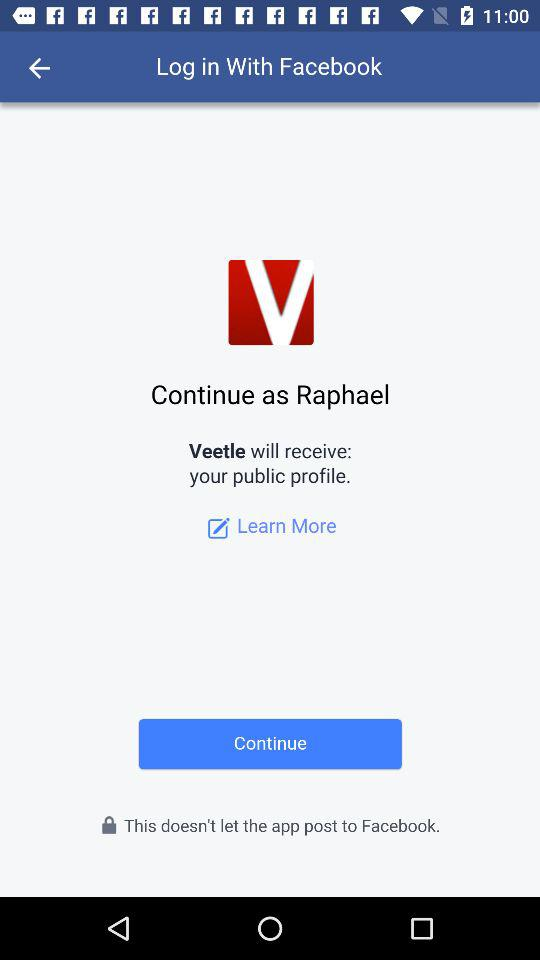What is the user name? The user name is Raphael. 